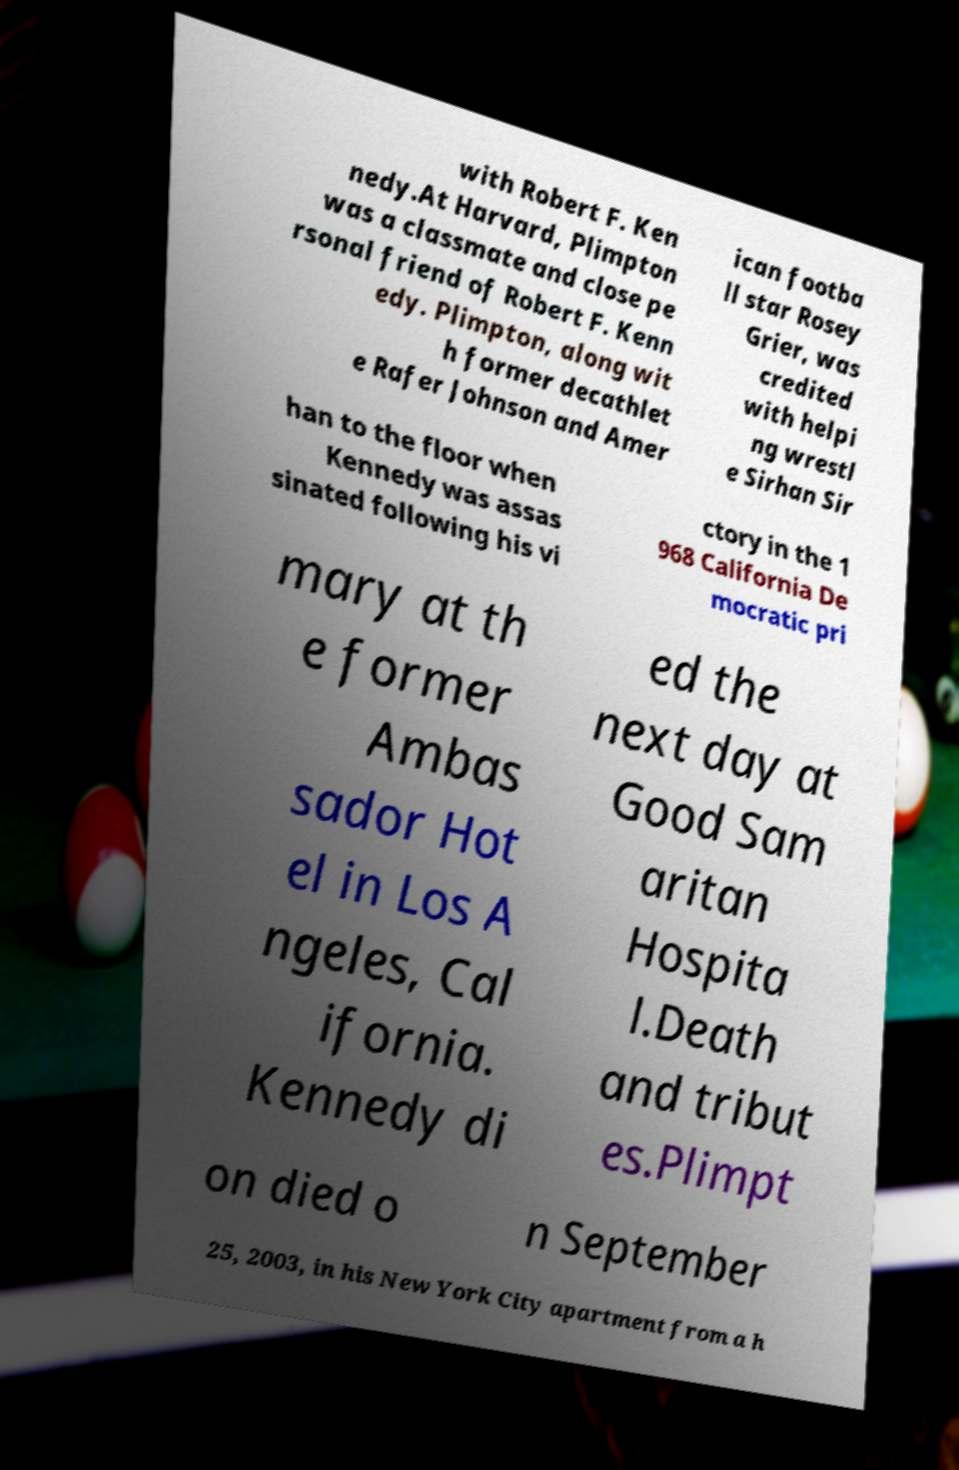Could you extract and type out the text from this image? with Robert F. Ken nedy.At Harvard, Plimpton was a classmate and close pe rsonal friend of Robert F. Kenn edy. Plimpton, along wit h former decathlet e Rafer Johnson and Amer ican footba ll star Rosey Grier, was credited with helpi ng wrestl e Sirhan Sir han to the floor when Kennedy was assas sinated following his vi ctory in the 1 968 California De mocratic pri mary at th e former Ambas sador Hot el in Los A ngeles, Cal ifornia. Kennedy di ed the next day at Good Sam aritan Hospita l.Death and tribut es.Plimpt on died o n September 25, 2003, in his New York City apartment from a h 